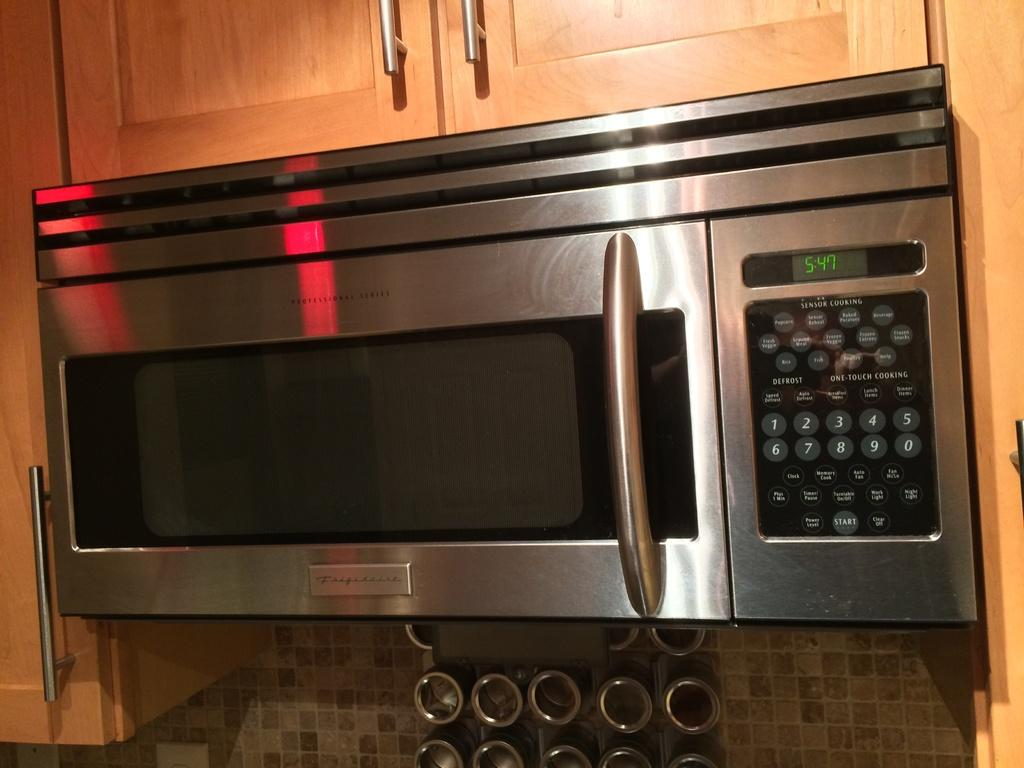<image>
Summarize the visual content of the image. A shiny, clean kitchen microwave shows the time as 5:47. 